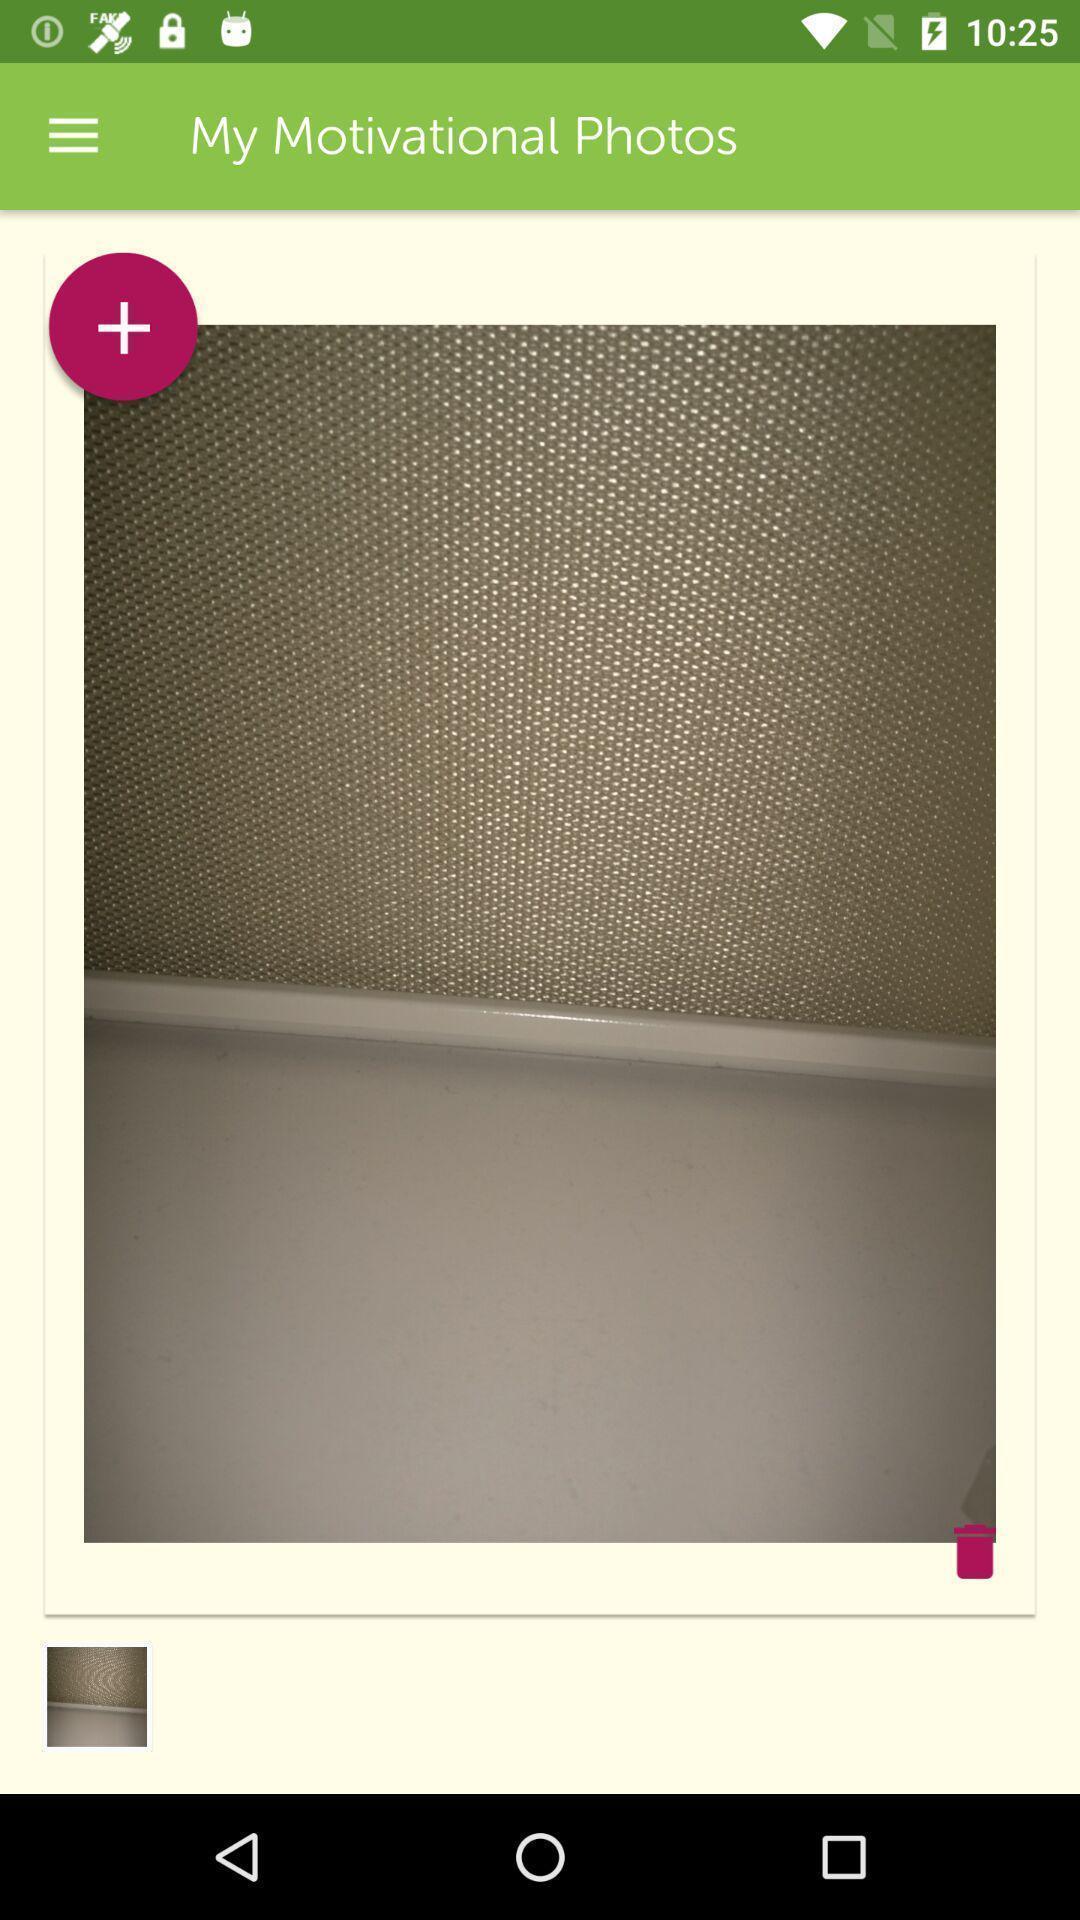What is the overall content of this screenshot? Page showing about motivational photos. 